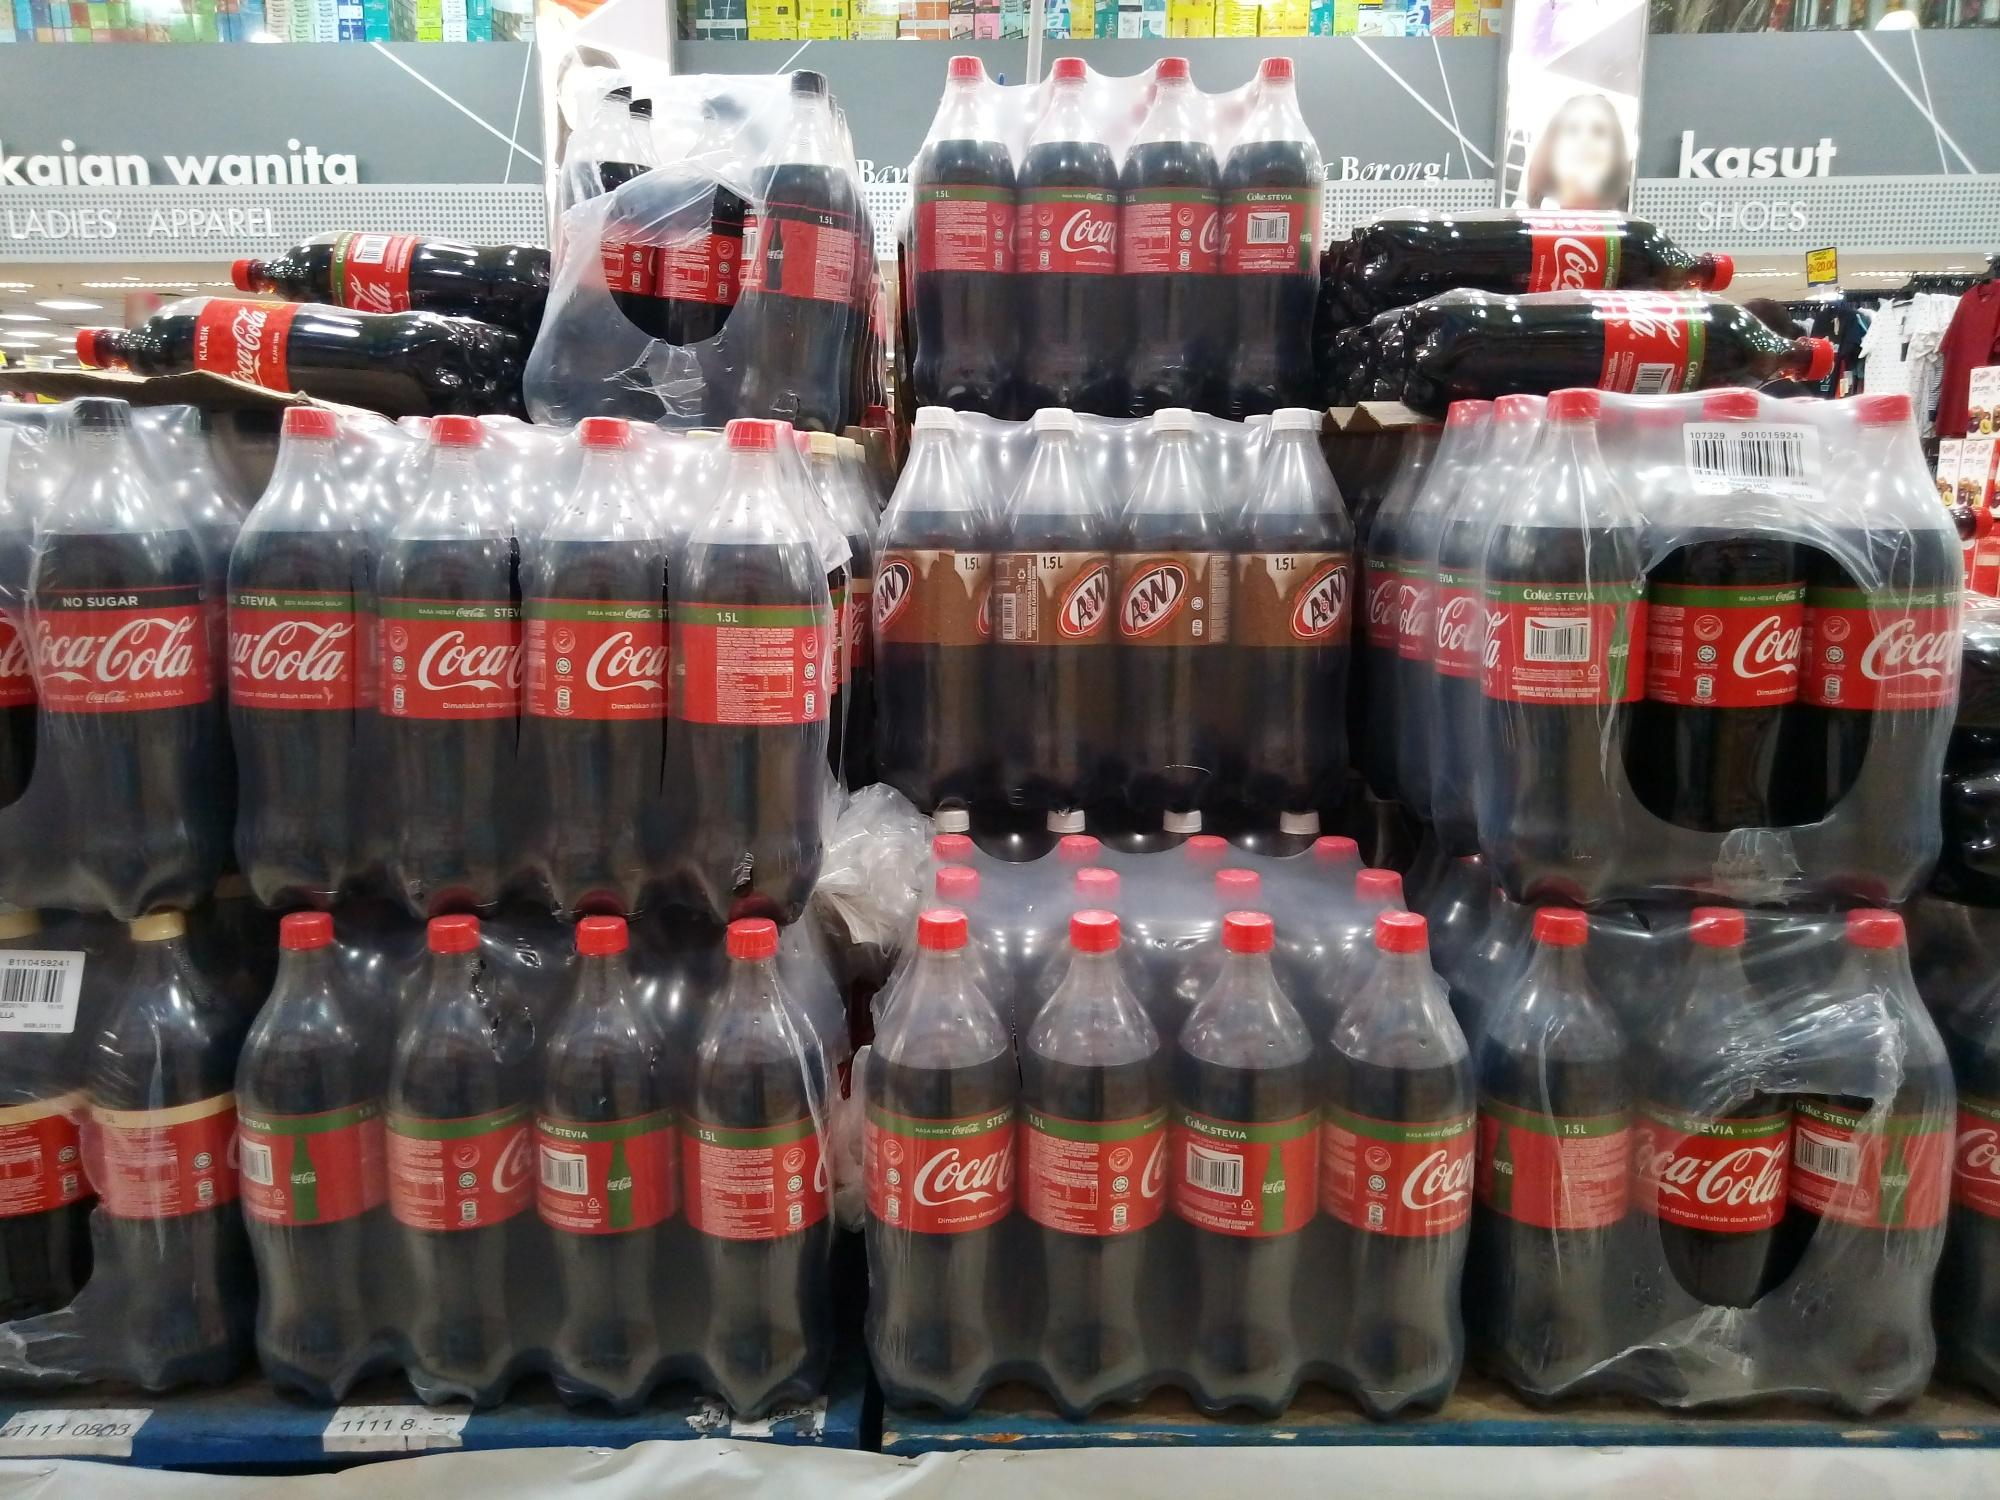Imagine these soda bottles coming to life after the store closes. How would they interact with each other and their surroundings? As the store's lights dim and the last customer leaves, the world of the soda bottles comes alive. The Coca-Cola bottles, animated with energy, start to shimmer under the fluorescent ceiling lights. They gather at the base of their pyramid, discussing the day's events. The A&W bottles, slightly more laid-back, join in, their brown labels gleaming warmly in the dark. Together, they explore the aisles of the store, occasionally pausing to admire their reflections in the polished floors. They share stories of being chosen by eager customers and speculate on what adventures lie beyond the store doors. Their camaraderie and curiosity turn the quiet night into a lively gathering, filled with laughter and tales of the human world. 